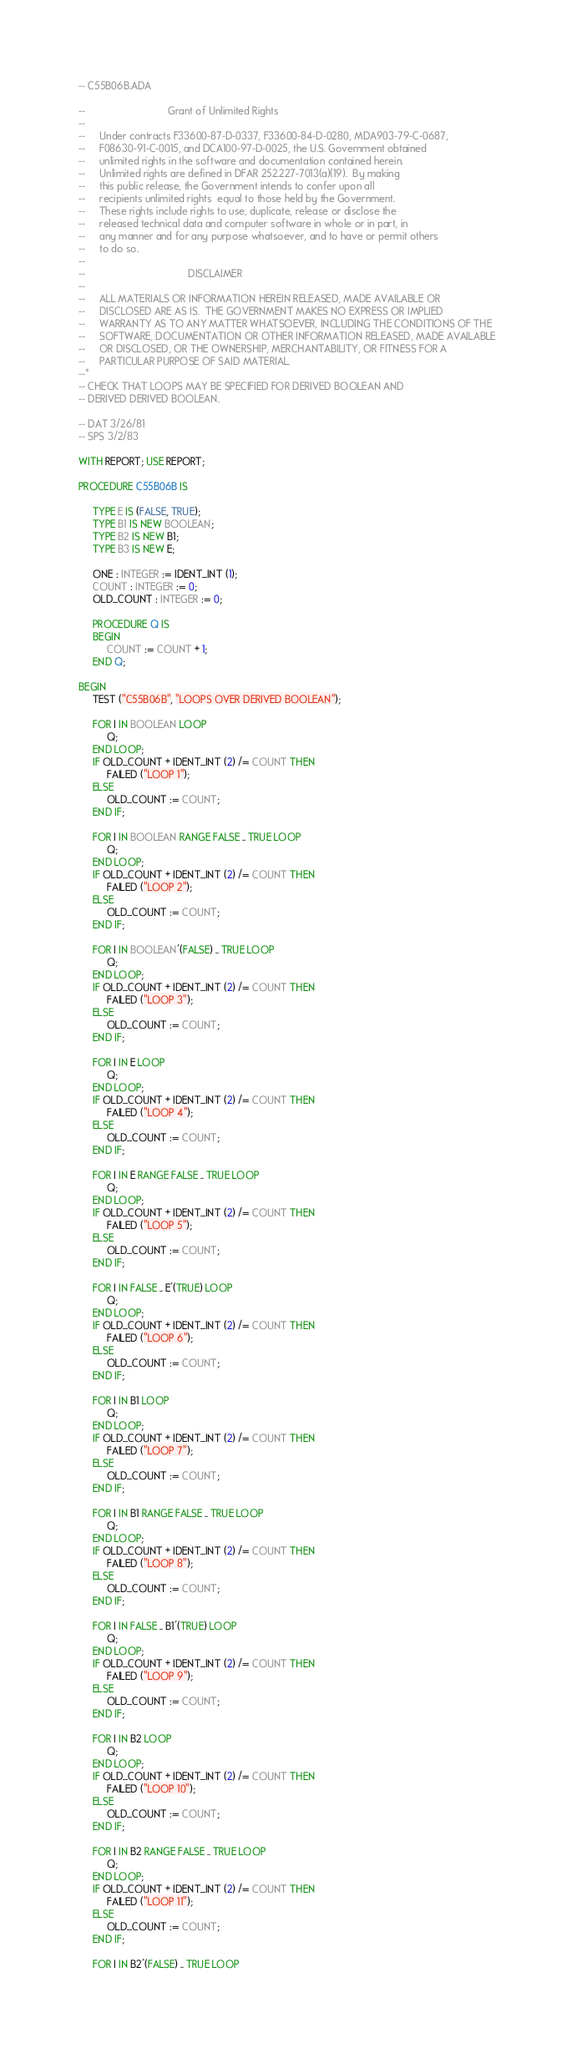<code> <loc_0><loc_0><loc_500><loc_500><_Ada_>-- C55B06B.ADA

--                             Grant of Unlimited Rights
--
--     Under contracts F33600-87-D-0337, F33600-84-D-0280, MDA903-79-C-0687,
--     F08630-91-C-0015, and DCA100-97-D-0025, the U.S. Government obtained 
--     unlimited rights in the software and documentation contained herein.
--     Unlimited rights are defined in DFAR 252.227-7013(a)(19).  By making 
--     this public release, the Government intends to confer upon all 
--     recipients unlimited rights  equal to those held by the Government.  
--     These rights include rights to use, duplicate, release or disclose the 
--     released technical data and computer software in whole or in part, in 
--     any manner and for any purpose whatsoever, and to have or permit others 
--     to do so.
--
--                                    DISCLAIMER
--
--     ALL MATERIALS OR INFORMATION HEREIN RELEASED, MADE AVAILABLE OR
--     DISCLOSED ARE AS IS.  THE GOVERNMENT MAKES NO EXPRESS OR IMPLIED 
--     WARRANTY AS TO ANY MATTER WHATSOEVER, INCLUDING THE CONDITIONS OF THE
--     SOFTWARE, DOCUMENTATION OR OTHER INFORMATION RELEASED, MADE AVAILABLE 
--     OR DISCLOSED, OR THE OWNERSHIP, MERCHANTABILITY, OR FITNESS FOR A
--     PARTICULAR PURPOSE OF SAID MATERIAL.
--*
-- CHECK THAT LOOPS MAY BE SPECIFIED FOR DERIVED BOOLEAN AND
-- DERIVED DERIVED BOOLEAN.

-- DAT 3/26/81
-- SPS 3/2/83

WITH REPORT; USE REPORT;

PROCEDURE C55B06B IS

     TYPE E IS (FALSE, TRUE);
     TYPE B1 IS NEW BOOLEAN;
     TYPE B2 IS NEW B1;
     TYPE B3 IS NEW E;

     ONE : INTEGER := IDENT_INT (1);
     COUNT : INTEGER := 0;
     OLD_COUNT : INTEGER := 0;

     PROCEDURE Q IS
     BEGIN
          COUNT := COUNT + 1;
     END Q;

BEGIN
     TEST ("C55B06B", "LOOPS OVER DERIVED BOOLEAN");

     FOR I IN BOOLEAN LOOP
          Q;
     END LOOP;
     IF OLD_COUNT + IDENT_INT (2) /= COUNT THEN
          FAILED ("LOOP 1");
     ELSE
          OLD_COUNT := COUNT;
     END IF;

     FOR I IN BOOLEAN RANGE FALSE .. TRUE LOOP
          Q;
     END LOOP;
     IF OLD_COUNT + IDENT_INT (2) /= COUNT THEN
          FAILED ("LOOP 2");
     ELSE
          OLD_COUNT := COUNT;
     END IF;

     FOR I IN BOOLEAN'(FALSE) .. TRUE LOOP
          Q;
     END LOOP;
     IF OLD_COUNT + IDENT_INT (2) /= COUNT THEN
          FAILED ("LOOP 3");
     ELSE
          OLD_COUNT := COUNT;
     END IF;

     FOR I IN E LOOP
          Q;
     END LOOP;
     IF OLD_COUNT + IDENT_INT (2) /= COUNT THEN
          FAILED ("LOOP 4");
     ELSE
          OLD_COUNT := COUNT;
     END IF;

     FOR I IN E RANGE FALSE .. TRUE LOOP
          Q;
     END LOOP;
     IF OLD_COUNT + IDENT_INT (2) /= COUNT THEN
          FAILED ("LOOP 5");
     ELSE
          OLD_COUNT := COUNT;
     END IF;

     FOR I IN FALSE .. E'(TRUE) LOOP
          Q;
     END LOOP;
     IF OLD_COUNT + IDENT_INT (2) /= COUNT THEN
          FAILED ("LOOP 6");
     ELSE
          OLD_COUNT := COUNT;
     END IF;

     FOR I IN B1 LOOP
          Q;
     END LOOP;
     IF OLD_COUNT + IDENT_INT (2) /= COUNT THEN
          FAILED ("LOOP 7");
     ELSE
          OLD_COUNT := COUNT;
     END IF;

     FOR I IN B1 RANGE FALSE .. TRUE LOOP
          Q;
     END LOOP;
     IF OLD_COUNT + IDENT_INT (2) /= COUNT THEN
          FAILED ("LOOP 8");
     ELSE
          OLD_COUNT := COUNT;
     END IF;

     FOR I IN FALSE .. B1'(TRUE) LOOP
          Q;
     END LOOP;
     IF OLD_COUNT + IDENT_INT (2) /= COUNT THEN
          FAILED ("LOOP 9");
     ELSE
          OLD_COUNT := COUNT;
     END IF;

     FOR I IN B2 LOOP
          Q;
     END LOOP;
     IF OLD_COUNT + IDENT_INT (2) /= COUNT THEN
          FAILED ("LOOP 10");
     ELSE
          OLD_COUNT := COUNT;
     END IF;

     FOR I IN B2 RANGE FALSE .. TRUE LOOP
          Q;
     END LOOP;
     IF OLD_COUNT + IDENT_INT (2) /= COUNT THEN
          FAILED ("LOOP 11");
     ELSE
          OLD_COUNT := COUNT;
     END IF;

     FOR I IN B2'(FALSE) .. TRUE LOOP</code> 